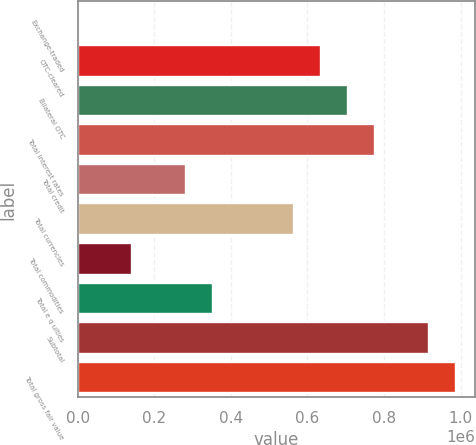<chart> <loc_0><loc_0><loc_500><loc_500><bar_chart><fcel>Exchange-traded<fcel>OTC-cleared<fcel>Bilateral OTC<fcel>Total interest rates<fcel>Total credit<fcel>Total currencies<fcel>Total commodities<fcel>Total e q uities<fcel>Subtotal<fcel>Total gross fair value<nl><fcel>443<fcel>635659<fcel>706239<fcel>776819<fcel>282761<fcel>565080<fcel>141602<fcel>353341<fcel>917978<fcel>988557<nl></chart> 